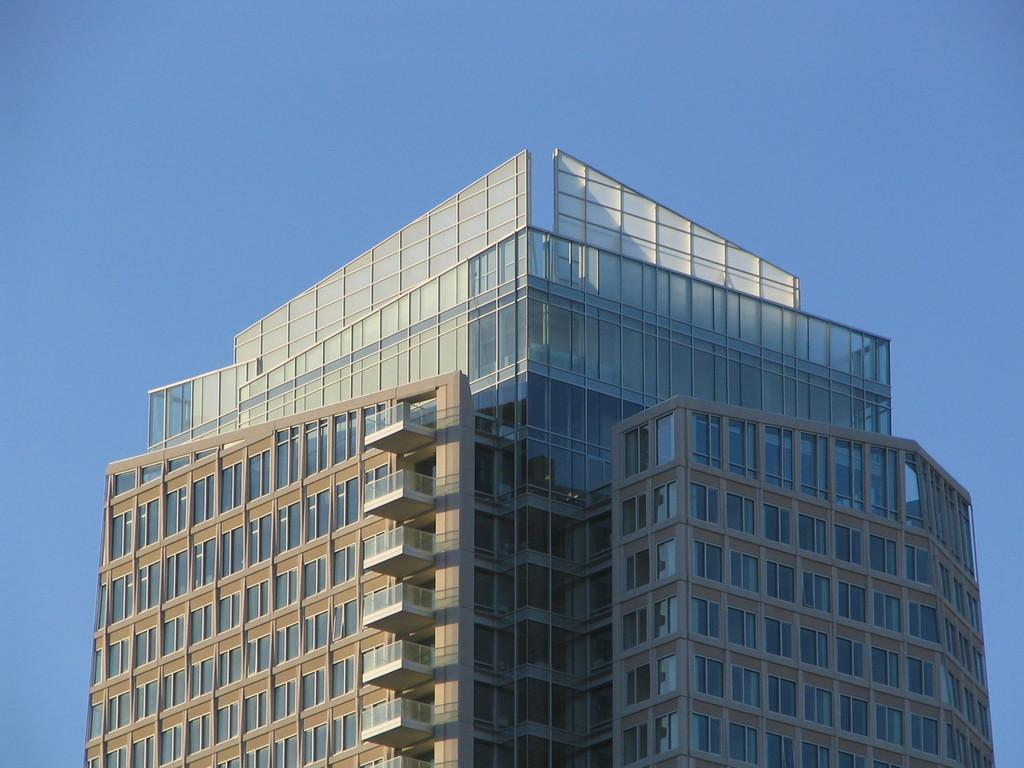What is the main subject of the picture? The main subject of the picture is a huge tower building. What specific features can be observed on the building? The building has windows and glasses. What can be seen in the background of the image? The sky is visible behind the building. How many dinosaurs can be seen playing in the shop near the building in the image? There are no dinosaurs or shops present in the image; it features a huge tower building with windows and glasses. 